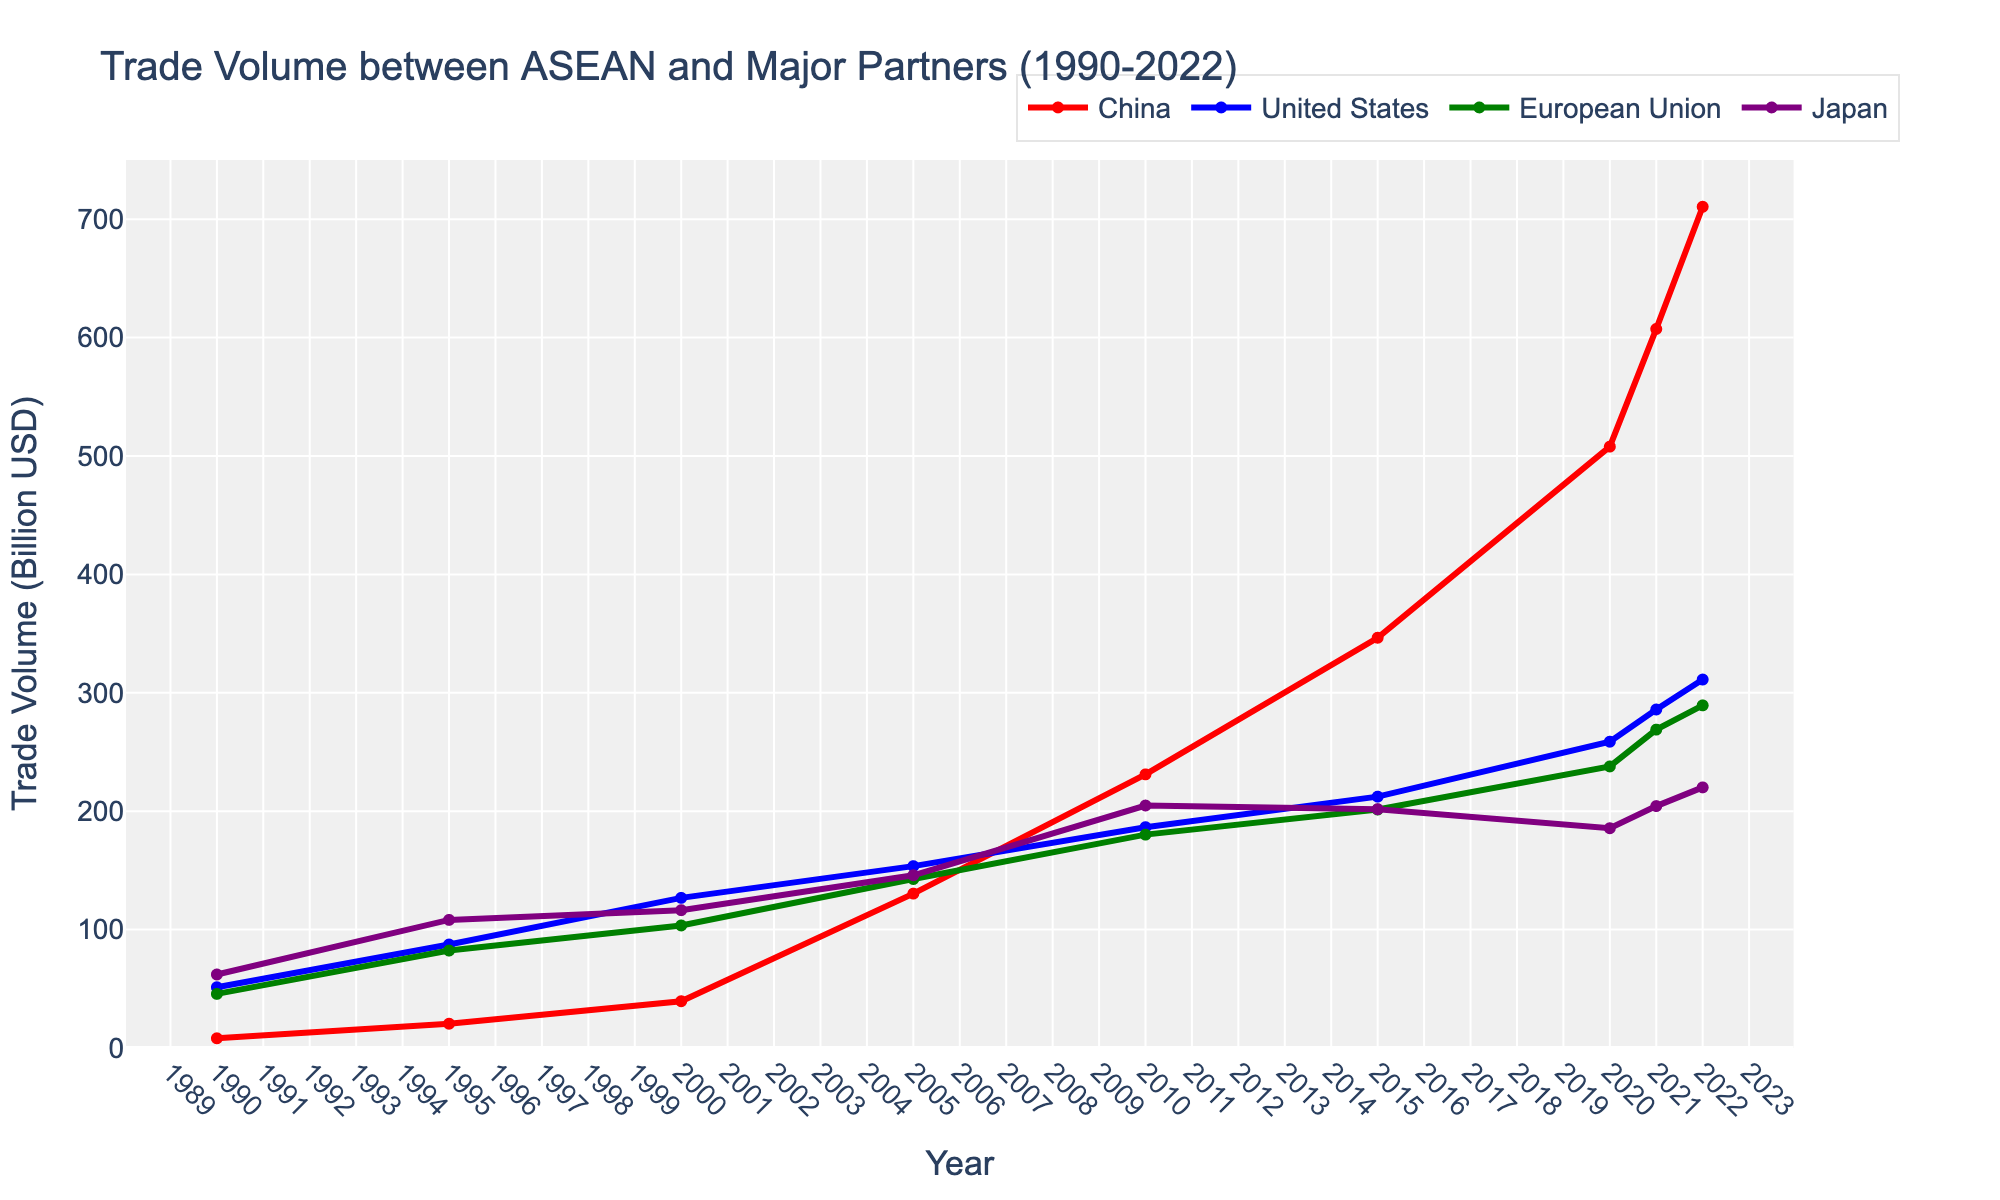What year did ASEAN have the highest trade volume with China? On the chart, find the point where the red line (representing China) reaches its highest value.
Answer: 2022 Which major trading partner had the lowest trade volume with ASEAN in 2022? On the chart, look at the different colored lines for the year 2022. Identify which line is the lowest.
Answer: Japan How does the trade volume with Japan in 1995 compare to that in 2022? Find the values for Japan in both 1995 and 2022 on the chart (purple line). Note their respective values and compare them.
Answer: 108.2 < 220.1 What is the average trade volume between ASEAN and the European Union from 2000 to 2020? Look at the values on the green line for the years 2000, 2005, 2010, 2015, and 2020. Sum these values and then divide by the number of years (5). (103.5 + 142.7 + 180.2 + 201.4 + 237.8) / 5 = 173.12
Answer: 173.12 By how much did the trade volume with the United States increase from 1990 to 2020? Find the trade volume values for the United States in 1990 and 2020 on the blue line. Subtract the 1990 value from the 2020 value. 258.7 - 51.3 = 207.4
Answer: 207.4 Which period saw the largest increase in trade volume with China? Observe the red line and identify the time span where the trade volume grew the most between two consecutive data points
Answer: 2015-2020 How did the trade volume trend with the European Union change between 2010 and 2022? Track the green line from 2010 to 2022 and describe its general direction and steepness.
Answer: Steady increase In what year did the trade volume between ASEAN and Japan begin to decrease after consistently rising? Observe the purple line and see where it peaks before it starts to decline.
Answer: 2015 